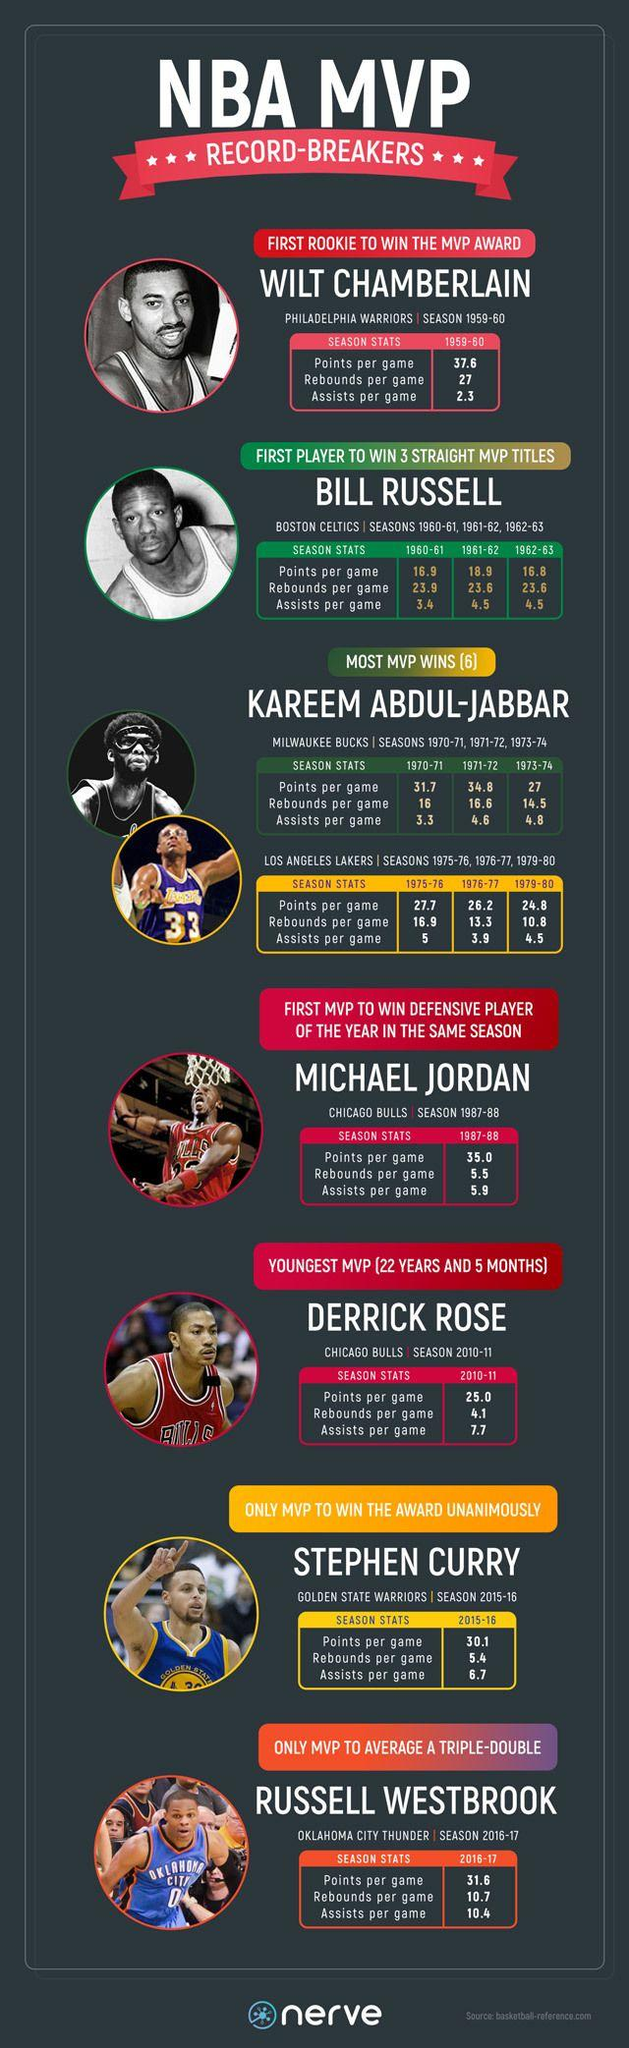List a handful of essential elements in this visual. In the 1973-74 season, Kareem Abdul-Jabbar averaged 14.5 rebounds per game, demonstrating his exceptional ability to secure defensive boards and contribute to the team's possession of the ball. Kareem Abdul-Jabbar, a renowned basketball player, has played for the Milwaukee Bucks and the Los Angeles Lakers. Bill Russell, in the 1961-62 season, averaged an impressive 23.6 rebounds per game, a testament to his dominance on the court. Derrick Rose's T-shirt is red in color. Bill Russell has played a total of 3 seasons. 